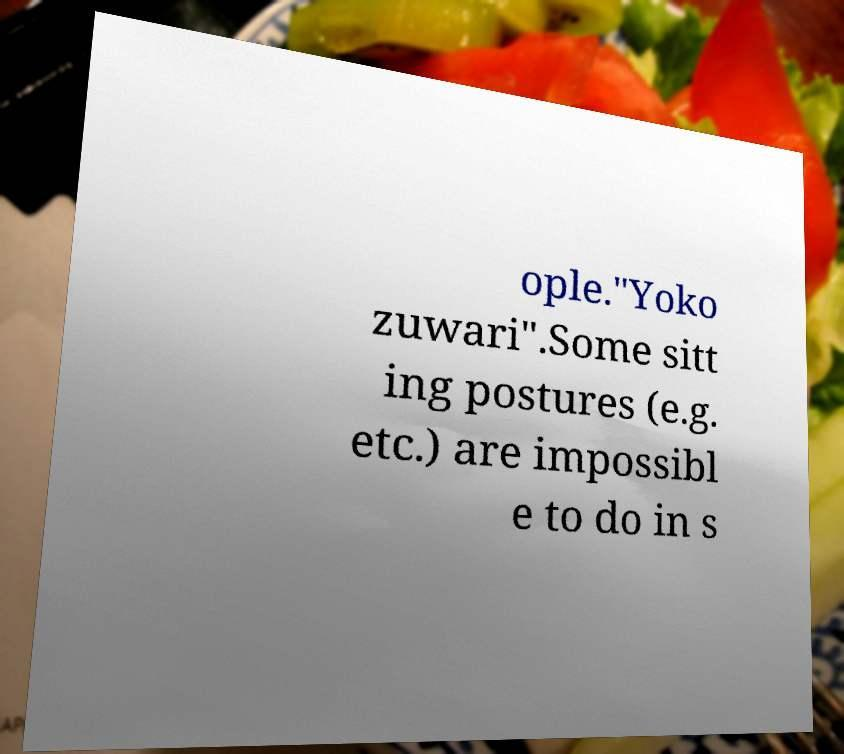There's text embedded in this image that I need extracted. Can you transcribe it verbatim? ople."Yoko zuwari".Some sitt ing postures (e.g. etc.) are impossibl e to do in s 